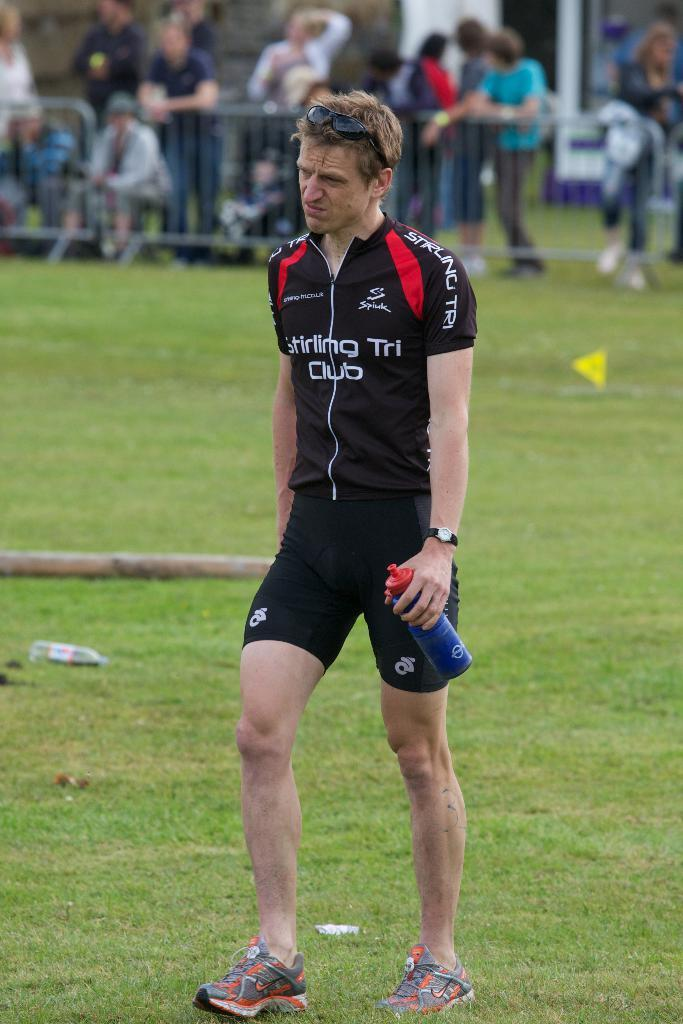<image>
Provide a brief description of the given image. A player for the Stirling Tri Club holds a water bottle and wears sunglasses. 